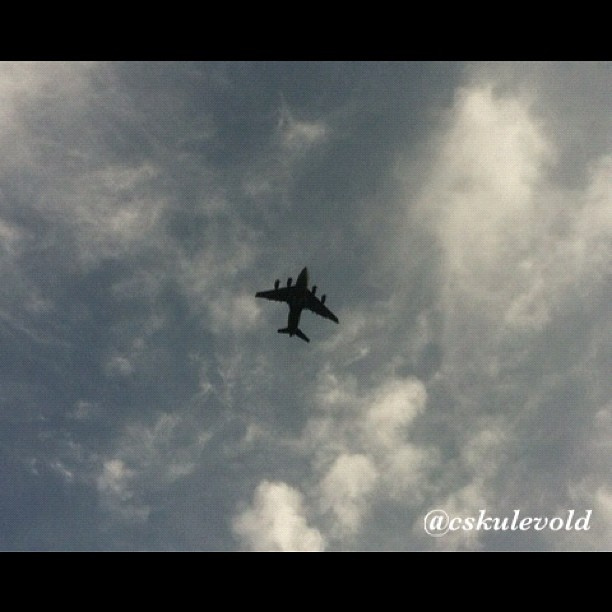<image>What is the magazine named? I am not sure what the magazine is named. It could be 'cskulevold' or 'eskulevold'. How many engines does the airplane have? It is unknown how many engines the airplane has. It could have anywhere between 1 and 4. How many engines does the airplane have? The airplane has 4 engines. What is the magazine named? I don't know the name of the magazine. It can be 'cskulevold', 'unknown', 'eskulevold', 'ackskulevold', 'none' or 'flying'. 